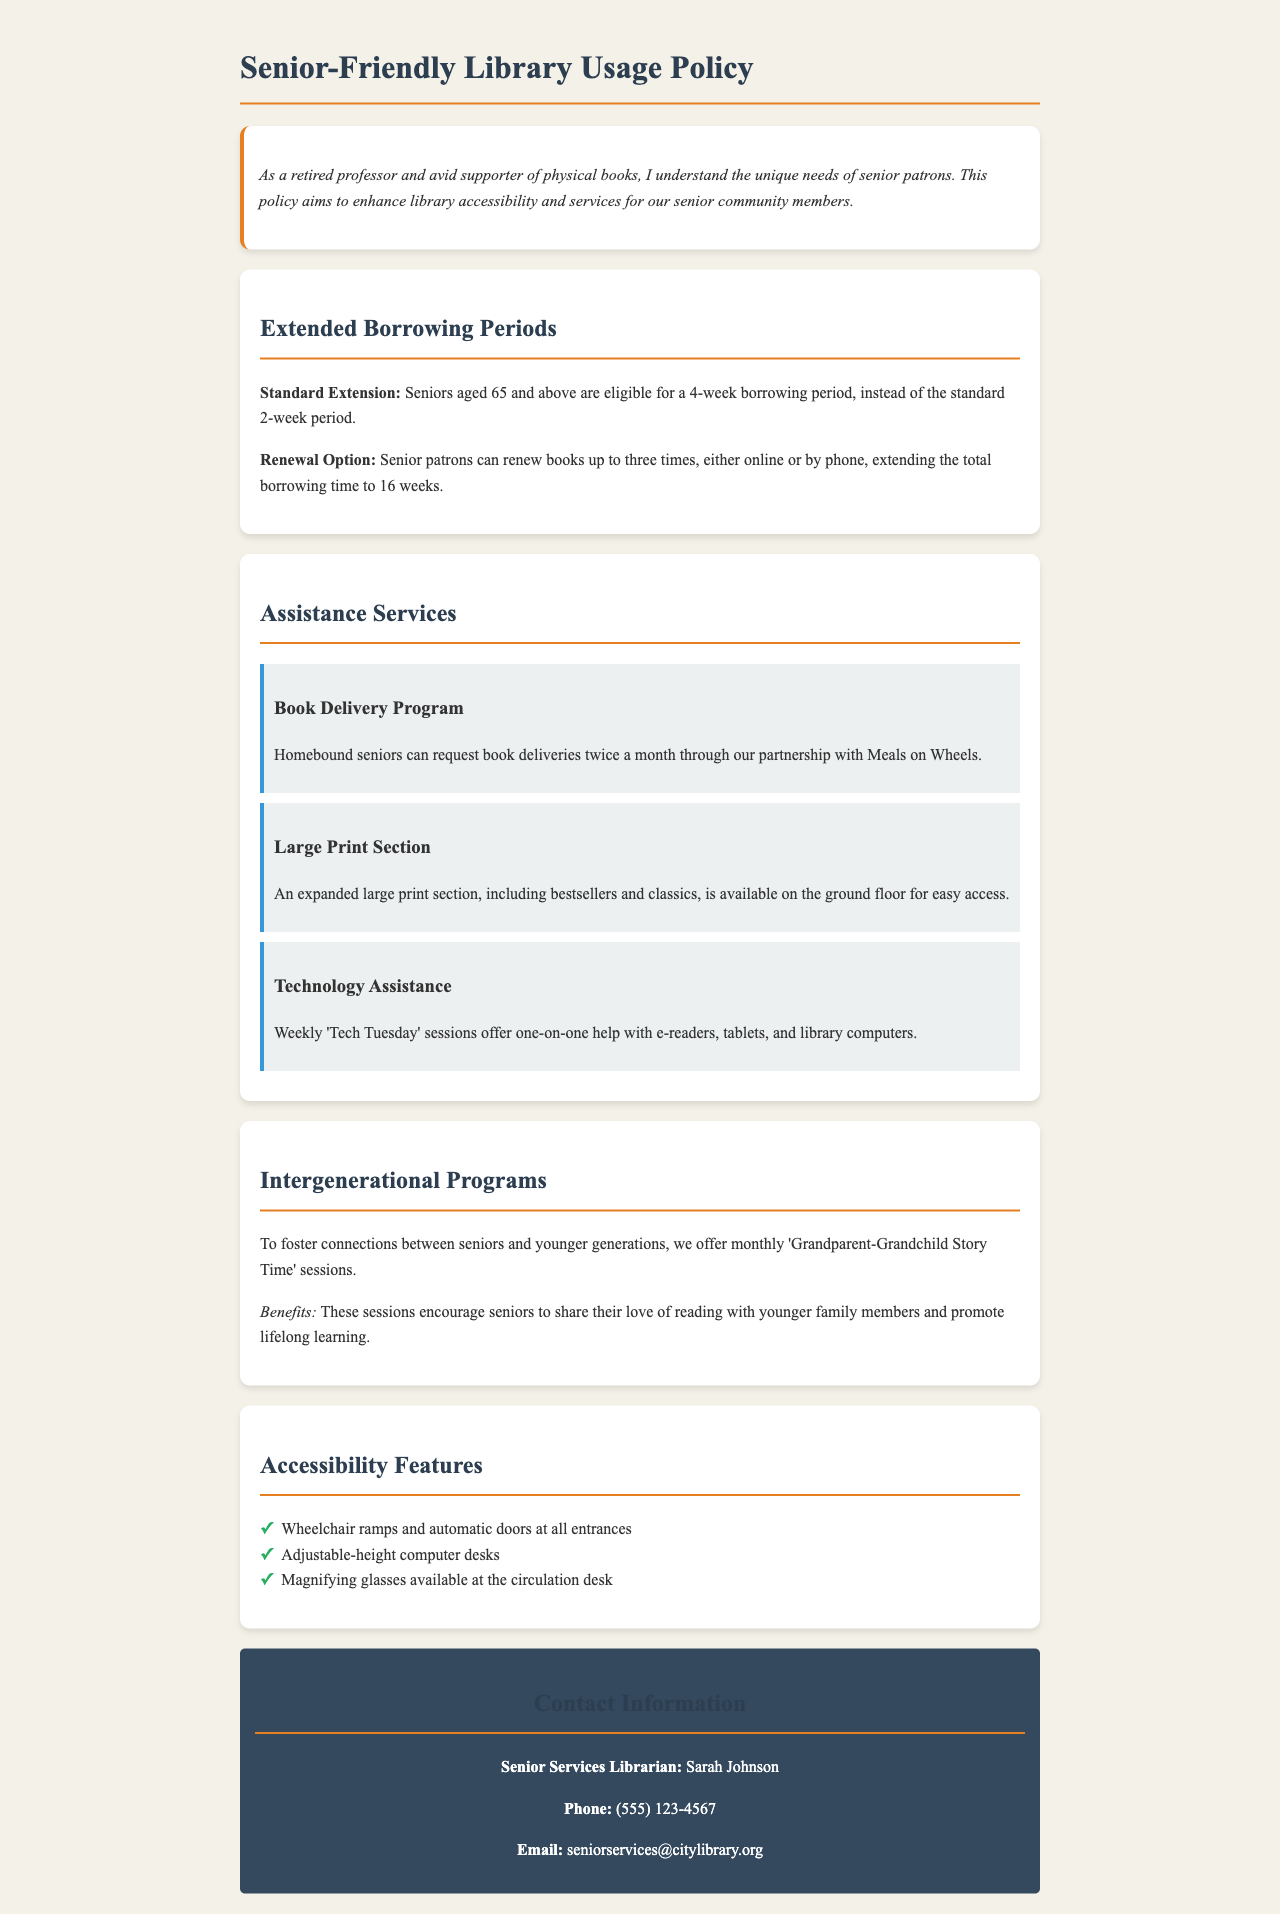What is the extended borrowing period for seniors? Seniors aged 65 and above are eligible for a 4-week borrowing period, instead of the standard 2-week period.
Answer: 4 weeks How many times can seniors renew books? Senior patrons can renew books up to three times, extending the total borrowing time to 16 weeks.
Answer: Three times What program is offered for homebound seniors? Homebound seniors can request book deliveries twice a month through a partnership with Meals on Wheels.
Answer: Book Delivery Program What is the focus of the monthly story time sessions? The sessions encourage seniors to share their love of reading with younger family members and promote lifelong learning.
Answer: Intergenerational Programs Who is the Senior Services Librarian? The contact person for senior services is Sarah Johnson.
Answer: Sarah Johnson What day are technology assistance sessions offered? Weekly 'Tech Tuesday' sessions provide help with technology.
Answer: Tuesday How many accessibility features are listed in the document? There are three accessibility features listed in the document.
Answer: Three features What is the total borrowing time for seniors if they renew their books? Seniors can extend the total borrowing time to 16 weeks by renewing their books three times.
Answer: 16 weeks What is available for easy access on the ground floor? An expanded large print section, including bestsellers and classics, is available for easy access.
Answer: Large Print Section 